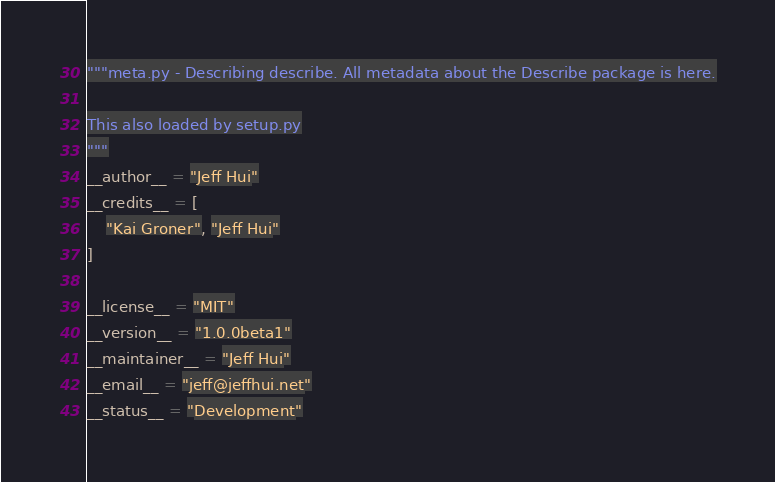<code> <loc_0><loc_0><loc_500><loc_500><_Python_>"""meta.py - Describing describe. All metadata about the Describe package is here.

This also loaded by setup.py
"""
__author__ = "Jeff Hui"
__credits__ = [
    "Kai Groner", "Jeff Hui"
]

__license__ = "MIT"
__version__ = "1.0.0beta1"
__maintainer__ = "Jeff Hui"
__email__ = "jeff@jeffhui.net"
__status__ = "Development"
</code> 